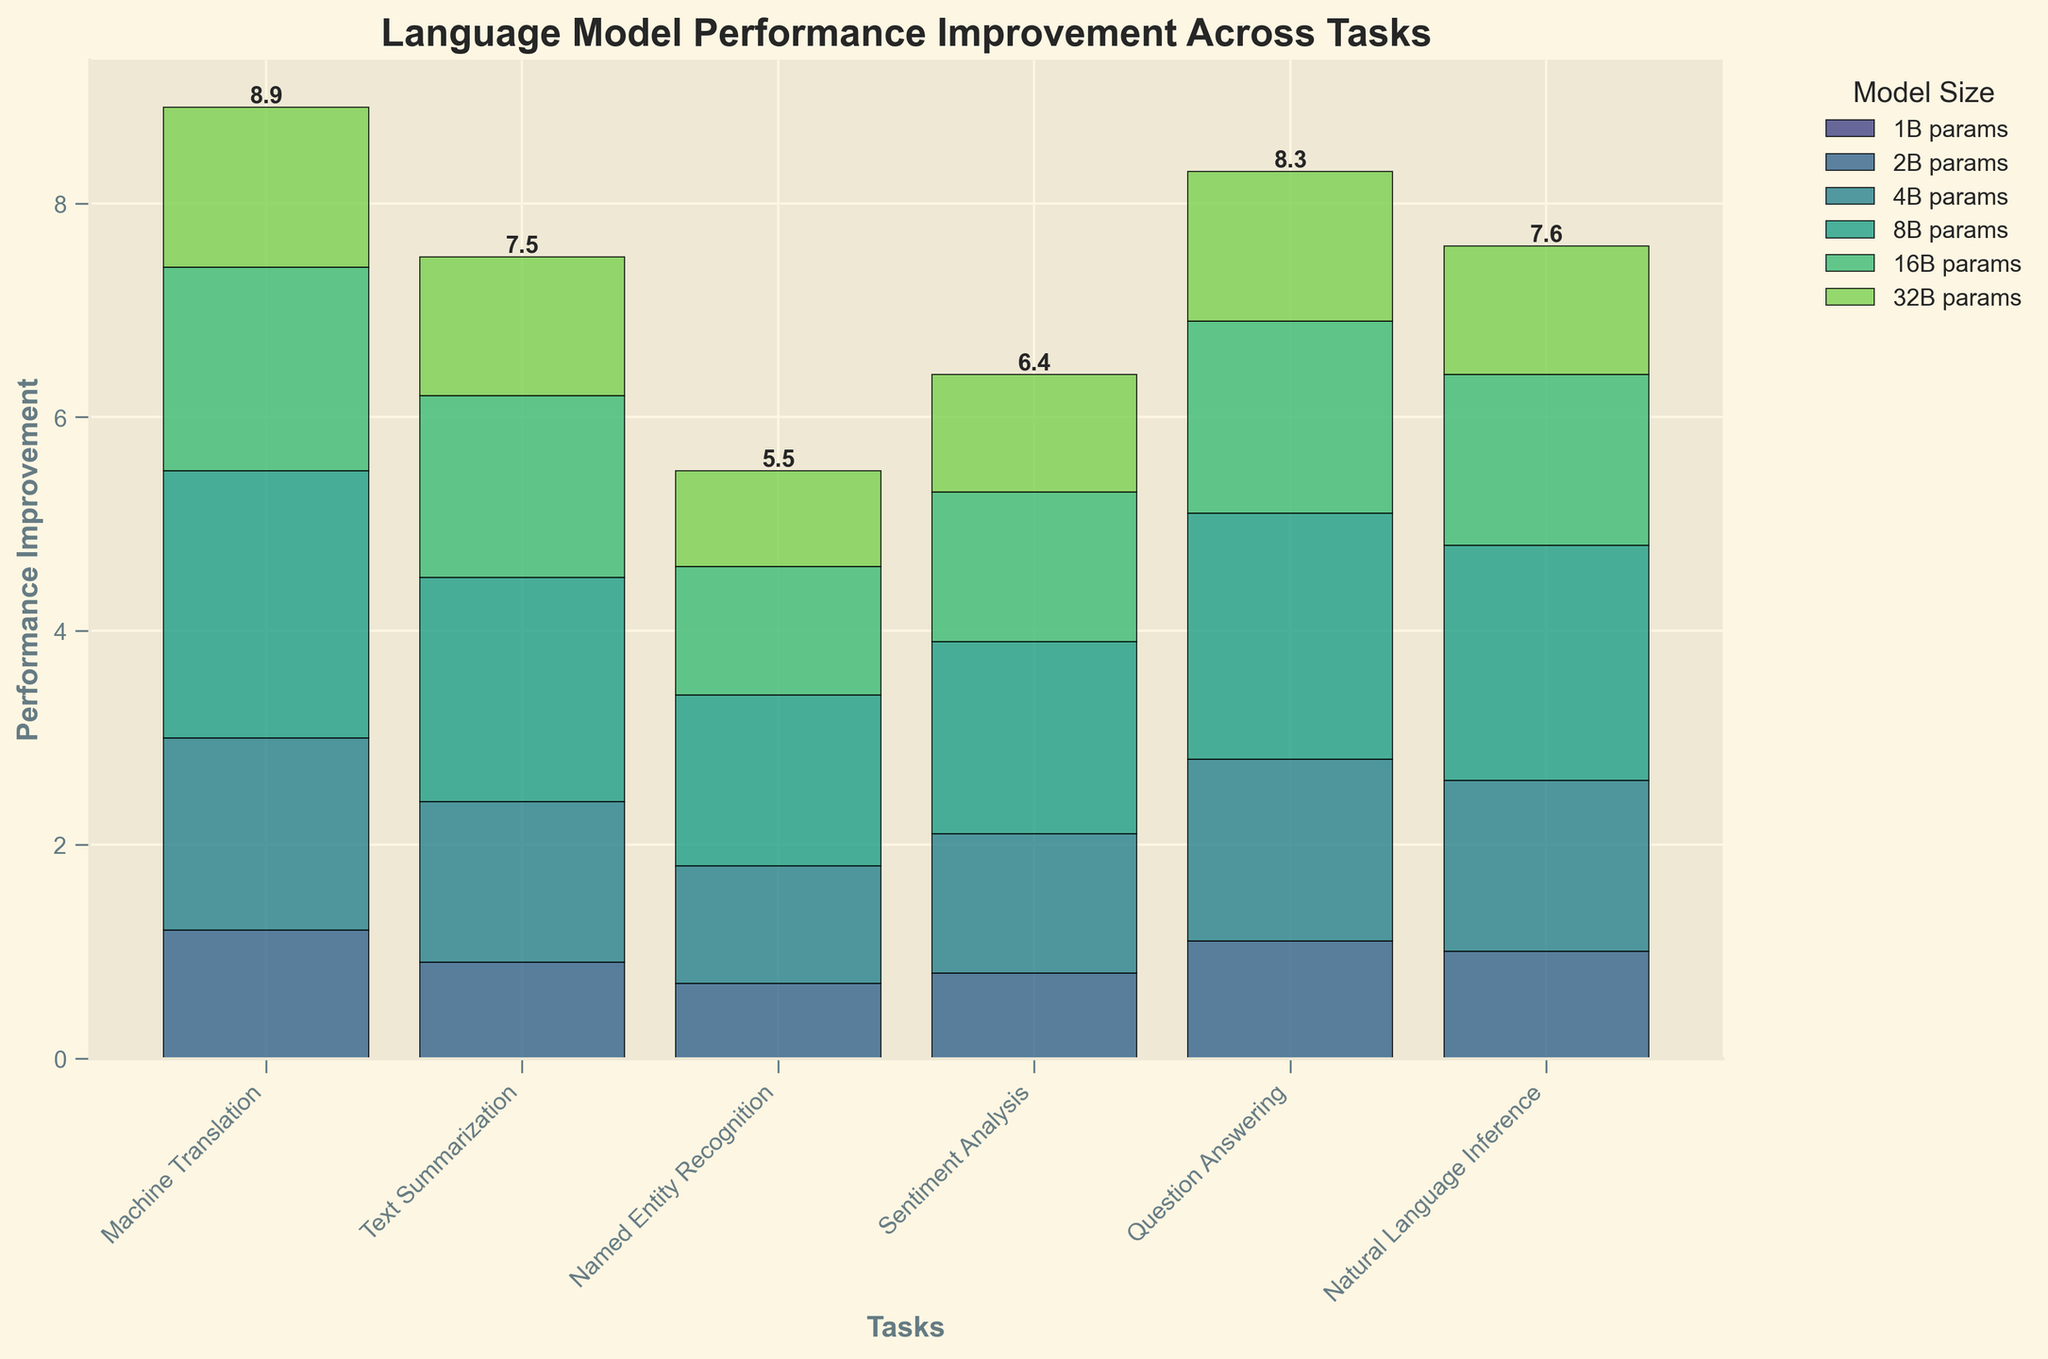What is the title of the waterflow chart? The title of the chart is prominently displayed at the top of the figure. It helps to understand the main subject or insight the chart is focused on.
Answer: Language Model Performance Improvement Across Tasks How would you describe the general trend in performance improvement as model size increases? The performance generally increases with larger model sizes up to a point, peaking around 8B parameters, and then begins to decline slightly as the model size continues to grow.
Answer: Peaks at 8B params, then declines Which task sees the highest performance improvement at 8B parameters? At 8B parameters, the height of the bars can be visually compared across different tasks to see which is the tallest.
Answer: Machine Translation Which task has the smallest performance improvement for the 32B params model? visually comparing the height of the bars at the 32B params level helps to identify the smallest improvement.
Answer: Named Entity Recognition What is the combined total performance improvement for Sentiment Analysis across all model sizes? Summing the heights of the bars for Sentiment Analysis at every model size.
Answer: 6.4 How does the performance improvement of Text Summarization at 16B params compare to Question Answering at 16B params? By visually comparing the heights of the bars for Text Summarization and Question Answering both at the 16B parameters level.
Answer: Text Summarization is smaller What is the average performance improvement for the Named Entity Recognition task across all model sizes? Adding the performance improvements for Named Entity Recognition for each model size and dividing by the number of model sizes.
Answer: 1.1 Which tasks see a decline in performance improvement beyond the 8B parameters model size? Comparing the heights of the bars beyond the 8B parameters model size for each task to see if they decrease.
Answer: All tasks What is the highest performance improvement mentioned for Natural Language Inference, and at what model size does it occur? Finding the tallest bar for Natural Language Inference and noting its model size.
Answer: 2.2 at 8B params Is there any task that increases consistently without decline as the model size increases? Evaluating the trend for each task across all model sizes to see if any task consistently increases without any decline.
Answer: No 